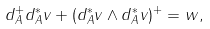<formula> <loc_0><loc_0><loc_500><loc_500>d _ { A } ^ { + } d _ { A } ^ { * } v + ( d _ { A } ^ { * } v \wedge d _ { A } ^ { * } v ) ^ { + } = w ,</formula> 